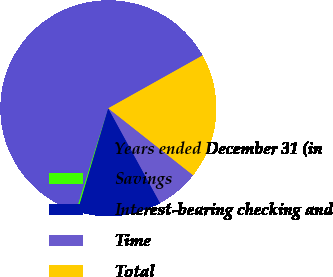<chart> <loc_0><loc_0><loc_500><loc_500><pie_chart><fcel>Years ended December 31 (in<fcel>Savings<fcel>Interest-bearing checking and<fcel>Time<fcel>Total<nl><fcel>62.03%<fcel>0.22%<fcel>12.58%<fcel>6.4%<fcel>18.76%<nl></chart> 